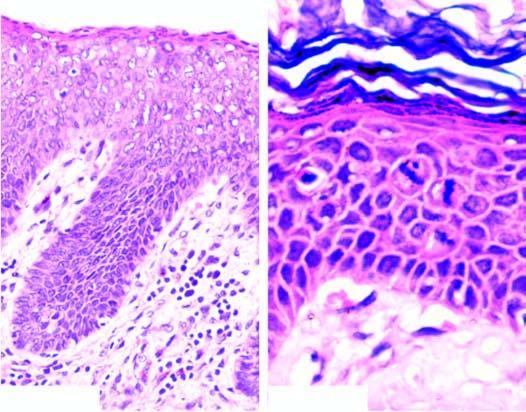what is there throughout the entire thickness of the epithelium?
Answer the question using a single word or phrase. Hyperkeratosis 